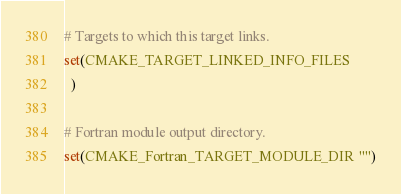Convert code to text. <code><loc_0><loc_0><loc_500><loc_500><_CMake_># Targets to which this target links.
set(CMAKE_TARGET_LINKED_INFO_FILES
  )

# Fortran module output directory.
set(CMAKE_Fortran_TARGET_MODULE_DIR "")
</code> 